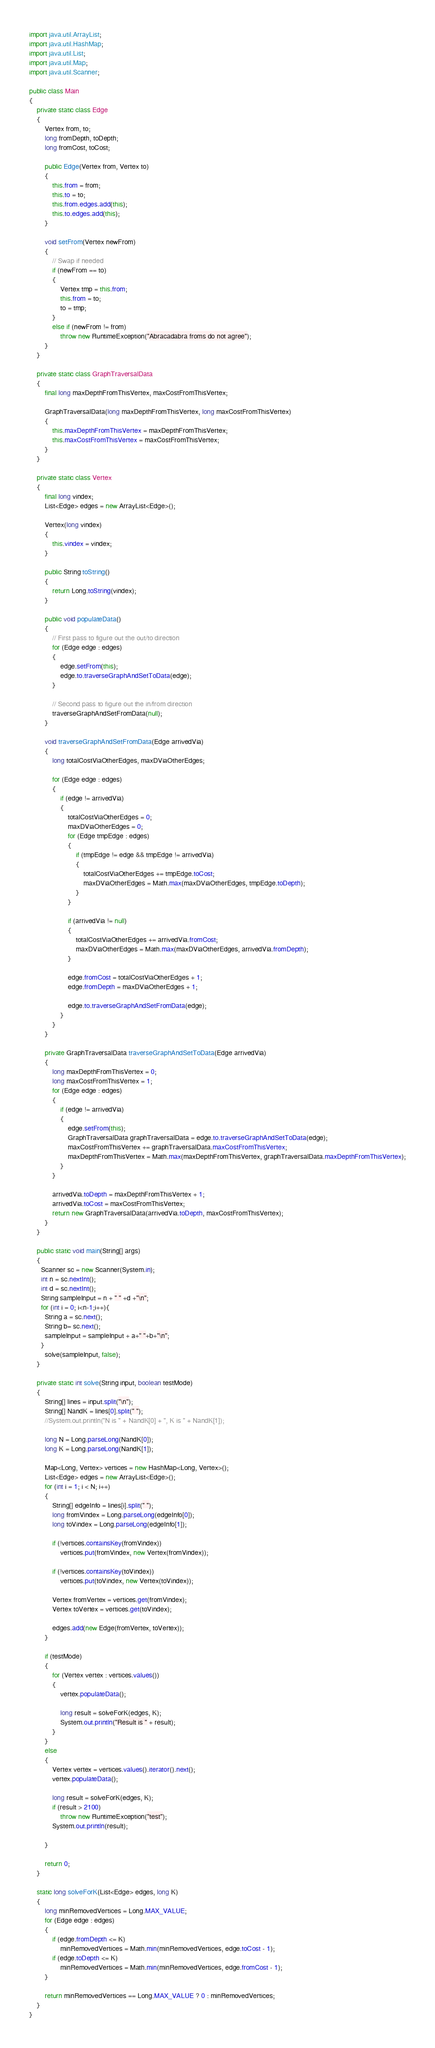<code> <loc_0><loc_0><loc_500><loc_500><_Java_>import java.util.ArrayList;
import java.util.HashMap;
import java.util.List;
import java.util.Map;
import java.util.Scanner;
 
public class Main
{
    private static class Edge
    {
        Vertex from, to;
        long fromDepth, toDepth;
        long fromCost, toCost;
 
        public Edge(Vertex from, Vertex to)
        {
            this.from = from;
            this.to = to;
            this.from.edges.add(this);
            this.to.edges.add(this);
        }
 
        void setFrom(Vertex newFrom)
        {
            // Swap if needed
            if (newFrom == to)
            {
                Vertex tmp = this.from;
                this.from = to;
                to = tmp;
            }
            else if (newFrom != from)
                throw new RuntimeException("Abracadabra froms do not agree");
        }
    }
 
    private static class GraphTraversalData
    {
        final long maxDepthFromThisVertex, maxCostFromThisVertex;
 
        GraphTraversalData(long maxDepthFromThisVertex, long maxCostFromThisVertex)
        {
            this.maxDepthFromThisVertex = maxDepthFromThisVertex;
            this.maxCostFromThisVertex = maxCostFromThisVertex;
        }
    }
 
    private static class Vertex
    {
        final long vindex;
        List<Edge> edges = new ArrayList<Edge>();
 
        Vertex(long vindex)
        {
            this.vindex = vindex;
        }
 
        public String toString()
        {
            return Long.toString(vindex);
        }
 
        public void populateData()
        {
            // First pass to figure out the out/to direction
            for (Edge edge : edges)
            {
                edge.setFrom(this);
                edge.to.traverseGraphAndSetToData(edge);
            }
 
            // Second pass to figure out the in/from direction
            traverseGraphAndSetFromData(null);
        }
 
        void traverseGraphAndSetFromData(Edge arrivedVia)
        {
            long totalCostViaOtherEdges, maxDViaOtherEdges;
 
            for (Edge edge : edges)
            {
                if (edge != arrivedVia)
                {
                    totalCostViaOtherEdges = 0;
                    maxDViaOtherEdges = 0;
                    for (Edge tmpEdge : edges)
                    {
                        if (tmpEdge != edge && tmpEdge != arrivedVia)
                        {
                            totalCostViaOtherEdges += tmpEdge.toCost;
                            maxDViaOtherEdges = Math.max(maxDViaOtherEdges, tmpEdge.toDepth);
                        }
                    }
 
                    if (arrivedVia != null)
                    {
                        totalCostViaOtherEdges += arrivedVia.fromCost;
                        maxDViaOtherEdges = Math.max(maxDViaOtherEdges, arrivedVia.fromDepth);
                    }
 
                    edge.fromCost = totalCostViaOtherEdges + 1;
                    edge.fromDepth = maxDViaOtherEdges + 1;
 
                    edge.to.traverseGraphAndSetFromData(edge);
                }
            }
        }
 
        private GraphTraversalData traverseGraphAndSetToData(Edge arrivedVia)
        {
            long maxDepthFromThisVertex = 0;
            long maxCostFromThisVertex = 1;
            for (Edge edge : edges)
            {
                if (edge != arrivedVia)
                {
                    edge.setFrom(this);
                    GraphTraversalData graphTraversalData = edge.to.traverseGraphAndSetToData(edge);
                    maxCostFromThisVertex += graphTraversalData.maxCostFromThisVertex;
                    maxDepthFromThisVertex = Math.max(maxDepthFromThisVertex, graphTraversalData.maxDepthFromThisVertex);
                }
            }
 
            arrivedVia.toDepth = maxDepthFromThisVertex + 1;
            arrivedVia.toCost = maxCostFromThisVertex;
            return new GraphTraversalData(arrivedVia.toDepth, maxCostFromThisVertex);
        }
    }
 
    public static void main(String[] args)
    {
      Scanner sc = new Scanner(System.in);
      int n = sc.nextInt();
      int d = sc.nextInt();
      String sampleInput = n + " " +d +"\n";
      for (int i = 0; i<n-1;i++){
        String a = sc.next();
        String b= sc.next();
        sampleInput = sampleInput + a+" "+b+"\n";
      }
        solve(sampleInput, false);
    }
 
    private static int solve(String input, boolean testMode)
    {
        String[] lines = input.split("\n");
        String[] NandK = lines[0].split(" ");
        //System.out.println("N is " + NandK[0] + ", K is " + NandK[1]);
 
        long N = Long.parseLong(NandK[0]);
        long K = Long.parseLong(NandK[1]);
 
        Map<Long, Vertex> vertices = new HashMap<Long, Vertex>();
        List<Edge> edges = new ArrayList<Edge>();
        for (int i = 1; i < N; i++)
        {
            String[] edgeInfo = lines[i].split(" ");
            long fromVindex = Long.parseLong(edgeInfo[0]);
            long toVindex = Long.parseLong(edgeInfo[1]);
 
            if (!vertices.containsKey(fromVindex))
                vertices.put(fromVindex, new Vertex(fromVindex));
 
            if (!vertices.containsKey(toVindex))
                vertices.put(toVindex, new Vertex(toVindex));
 
            Vertex fromVertex = vertices.get(fromVindex);
            Vertex toVertex = vertices.get(toVindex);
 
            edges.add(new Edge(fromVertex, toVertex));
        }
 
        if (testMode)
        {
            for (Vertex vertex : vertices.values())
            {
                vertex.populateData();
 
                long result = solveForK(edges, K);
                System.out.println("Result is " + result);
            }
        }
        else
        {
            Vertex vertex = vertices.values().iterator().next();
            vertex.populateData();
 
            long result = solveForK(edges, K);
            if (result > 2100)
                throw new RuntimeException("test");
            System.out.println(result);
            
        }
 
        return 0;
    }
 
    static long solveForK(List<Edge> edges, long K)
    {
        long minRemovedVertices = Long.MAX_VALUE;
        for (Edge edge : edges)
        {
            if (edge.fromDepth <= K)
                minRemovedVertices = Math.min(minRemovedVertices, edge.toCost - 1);
            if (edge.toDepth <= K)
                minRemovedVertices = Math.min(minRemovedVertices, edge.fromCost - 1);
        }
 
        return minRemovedVertices == Long.MAX_VALUE ? 0 : minRemovedVertices;
    }
}</code> 